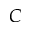Convert formula to latex. <formula><loc_0><loc_0><loc_500><loc_500>C</formula> 